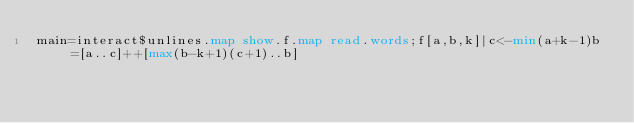Convert code to text. <code><loc_0><loc_0><loc_500><loc_500><_Haskell_>main=interact$unlines.map show.f.map read.words;f[a,b,k]|c<-min(a+k-1)b=[a..c]++[max(b-k+1)(c+1)..b]</code> 